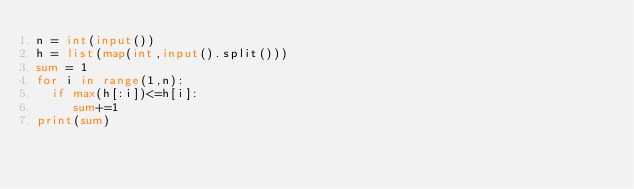Convert code to text. <code><loc_0><loc_0><loc_500><loc_500><_Python_>n = int(input())
h = list(map(int,input().split()))
sum = 1
for i in range(1,n):
  if max(h[:i])<=h[i]:
     sum+=1
print(sum)</code> 